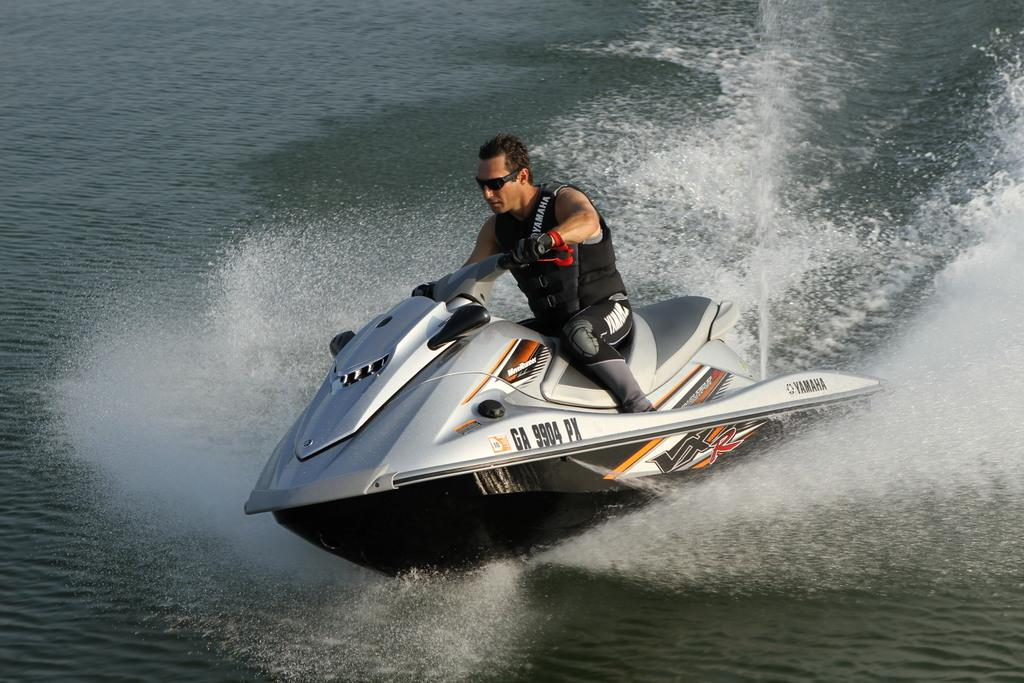What is the main subject of the image? The main subject of the image is a man. What is the man doing in the image? The man is riding a speed boat in the image. What is the man wearing in the image? The man is wearing a black dress in the image. What type of environment is visible in the image? There is water visible in the image. What type of stamp can be seen on the street in the image? There is no stamp or street present in the image; it features a man riding a speed boat in water. What is the taste of the water in the image? The taste of the water cannot be determined from the image, as taste is not a visual characteristic. 